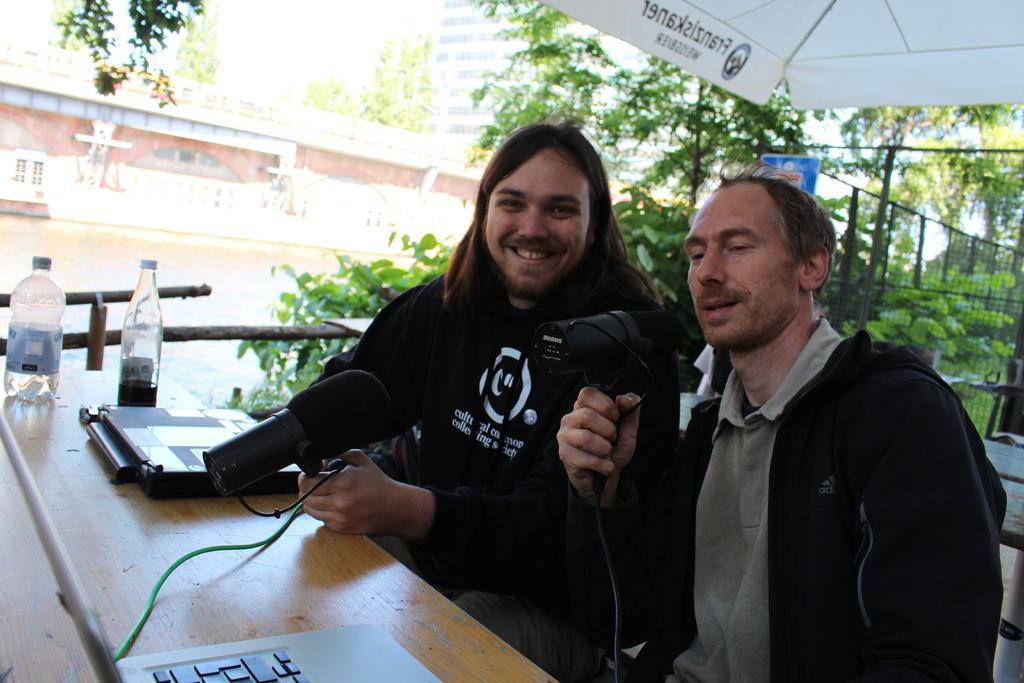How would you summarize this image in a sentence or two? In this image two persons are sitting wearing winter clothes. They are holding mics. In front of them on a table there is a laptop, bottles. In the background there are trees, buildings. Here there is boundary. On the top there is shelter. 